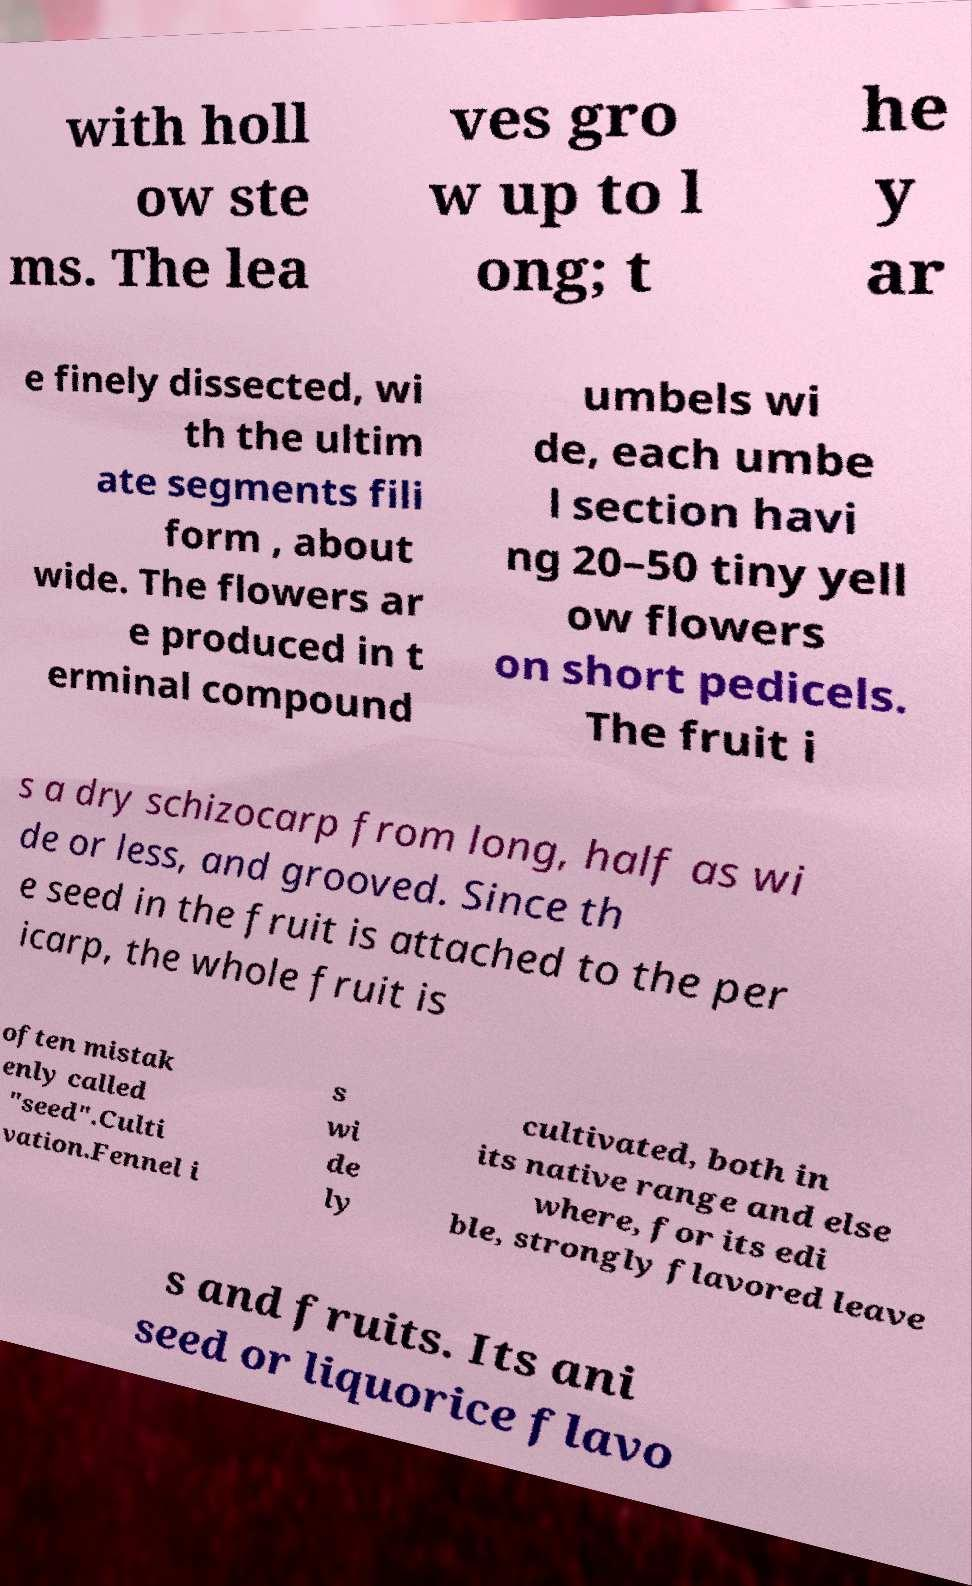Please identify and transcribe the text found in this image. with holl ow ste ms. The lea ves gro w up to l ong; t he y ar e finely dissected, wi th the ultim ate segments fili form , about wide. The flowers ar e produced in t erminal compound umbels wi de, each umbe l section havi ng 20–50 tiny yell ow flowers on short pedicels. The fruit i s a dry schizocarp from long, half as wi de or less, and grooved. Since th e seed in the fruit is attached to the per icarp, the whole fruit is often mistak enly called "seed".Culti vation.Fennel i s wi de ly cultivated, both in its native range and else where, for its edi ble, strongly flavored leave s and fruits. Its ani seed or liquorice flavo 